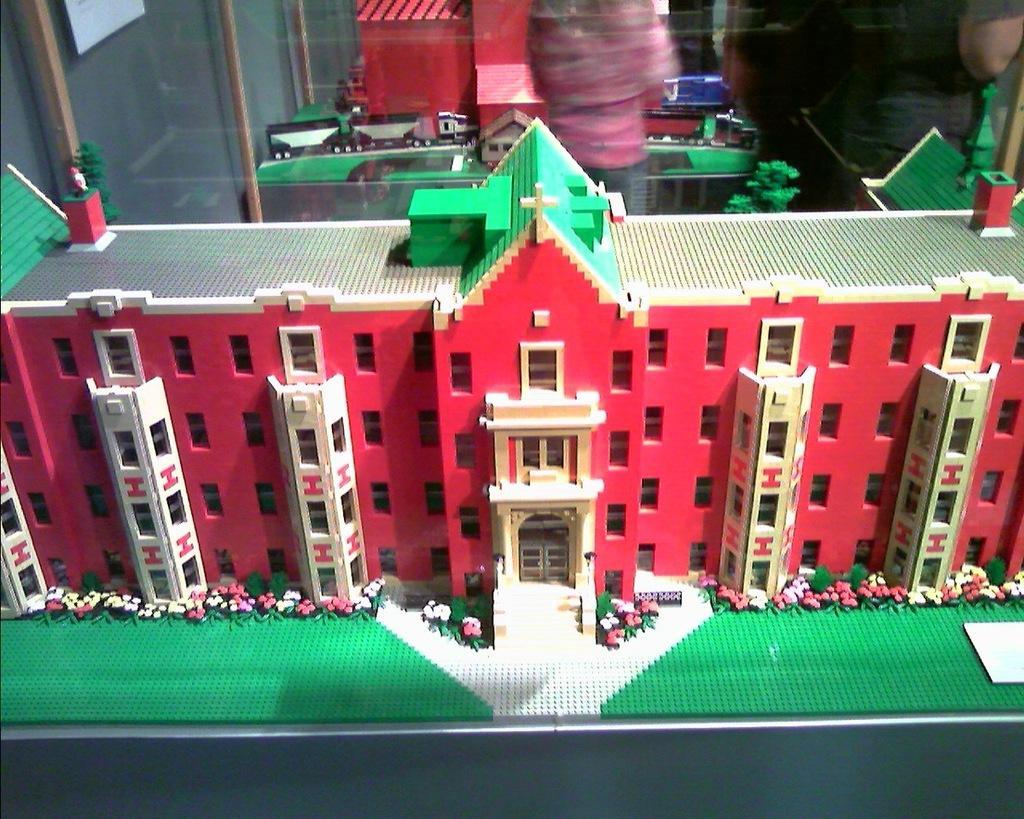How would you summarize this image in a sentence or two? At the bottom of this image, there is a model building. In the background, there is a transparent glass. Through this transparent glass, we can see there is another model building and other objects. And the background is dark in color. 